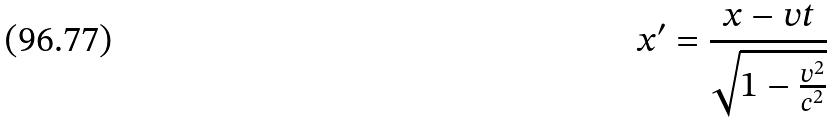<formula> <loc_0><loc_0><loc_500><loc_500>x ^ { \prime } = \frac { x - v t } { \sqrt { 1 - \frac { v ^ { 2 } } { c ^ { 2 } } } }</formula> 